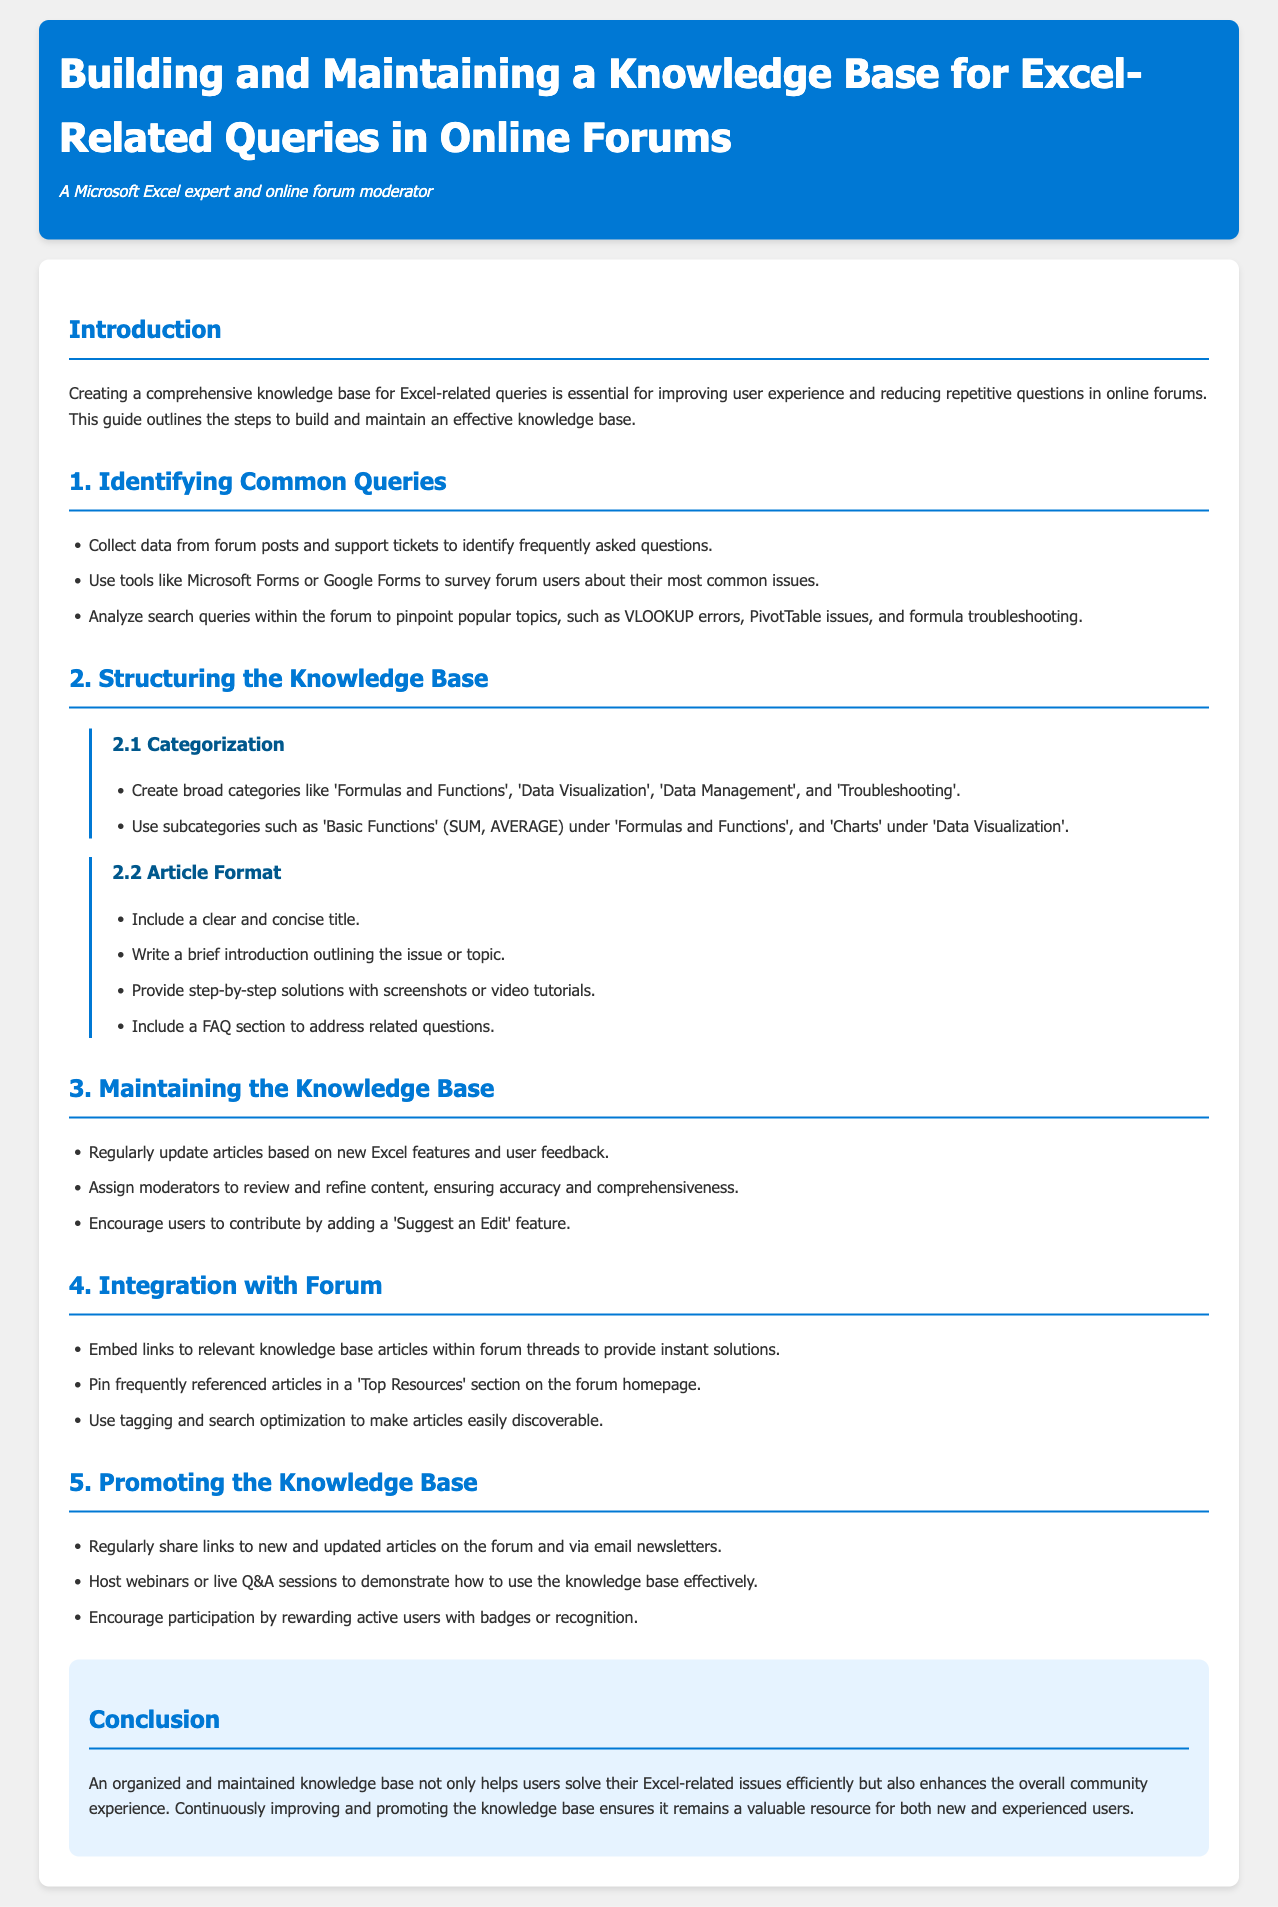what is the title of the document? The title is displayed prominently in the header section of the document.
Answer: Building and Maintaining a Knowledge Base for Excel-Related Queries in Online Forums how many main sections are in the document? The document lists six distinct sections including the introduction and conclusion.
Answer: 6 what are the broad categories suggested for the knowledge base? The document outlines specific categories for organizing the knowledge base in section 2.1.
Answer: Formulas and Functions, Data Visualization, Data Management, Troubleshooting what should be included in the article format? The document specifies the necessary elements for structuring an article in section 2.2.
Answer: Clear title, introduction, step-by-step solutions, FAQ section why is it important to maintain the knowledge base? The reason for maintaining the knowledge base is highlighted in section 3 regarding updates and user contributions.
Answer: To ensure accuracy and comprehensiveness how can users suggest edits to the knowledge base? The document discusses a feature that allows users to submit suggestions in section 3.
Answer: 'Suggest an Edit' feature what is a recommended way to promote the knowledge base? The document provides multiple ways to promote the knowledge base in section 5.
Answer: Share links to new articles what role do moderators play in maintaining the knowledge base? The document describes the responsibilities assigned to moderators concerning content management in section 3.
Answer: Review and refine content 